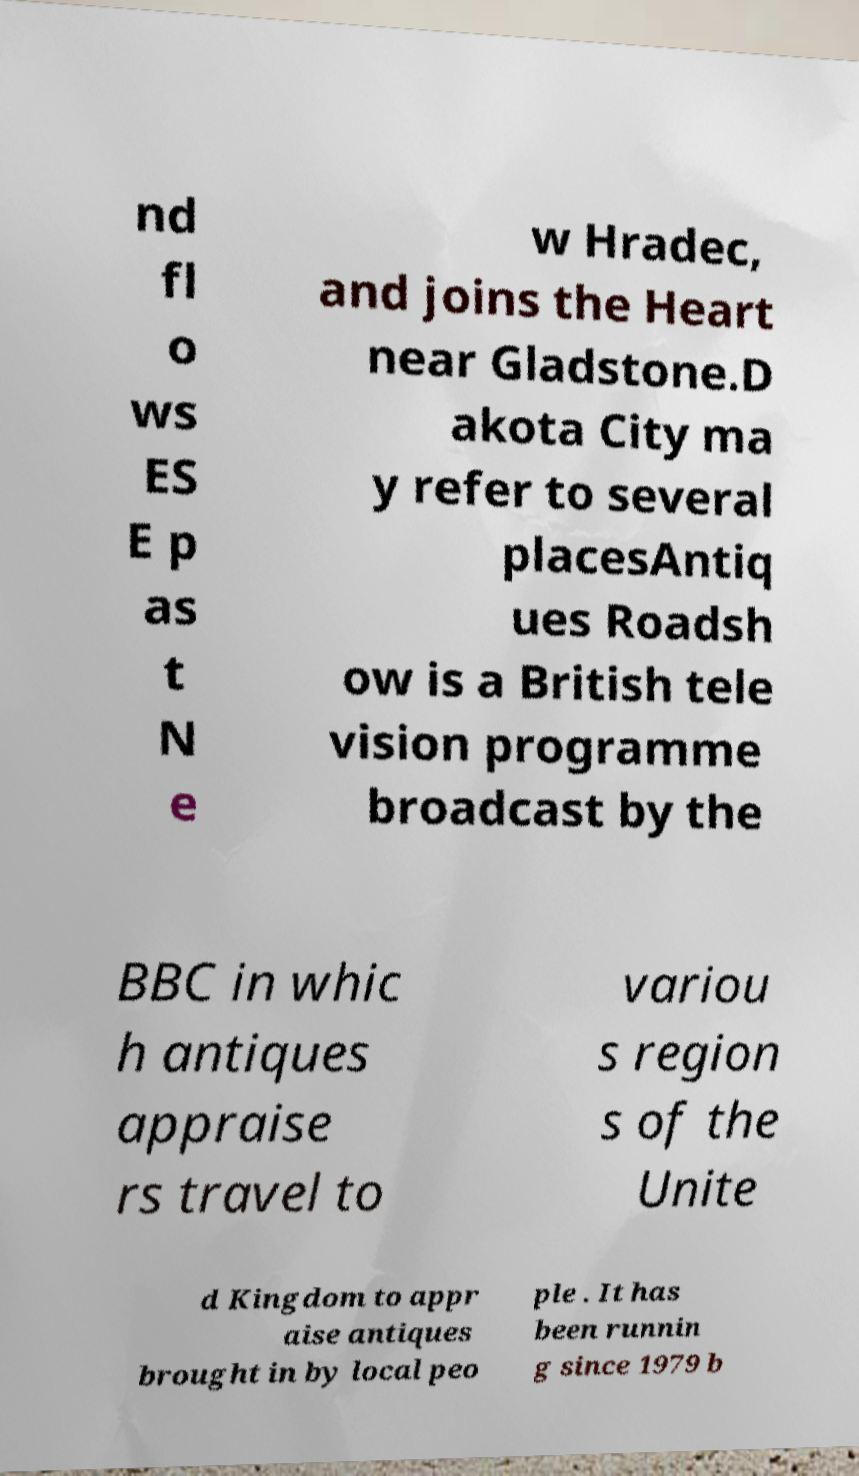Please read and relay the text visible in this image. What does it say? nd fl o ws ES E p as t N e w Hradec, and joins the Heart near Gladstone.D akota City ma y refer to several placesAntiq ues Roadsh ow is a British tele vision programme broadcast by the BBC in whic h antiques appraise rs travel to variou s region s of the Unite d Kingdom to appr aise antiques brought in by local peo ple . It has been runnin g since 1979 b 